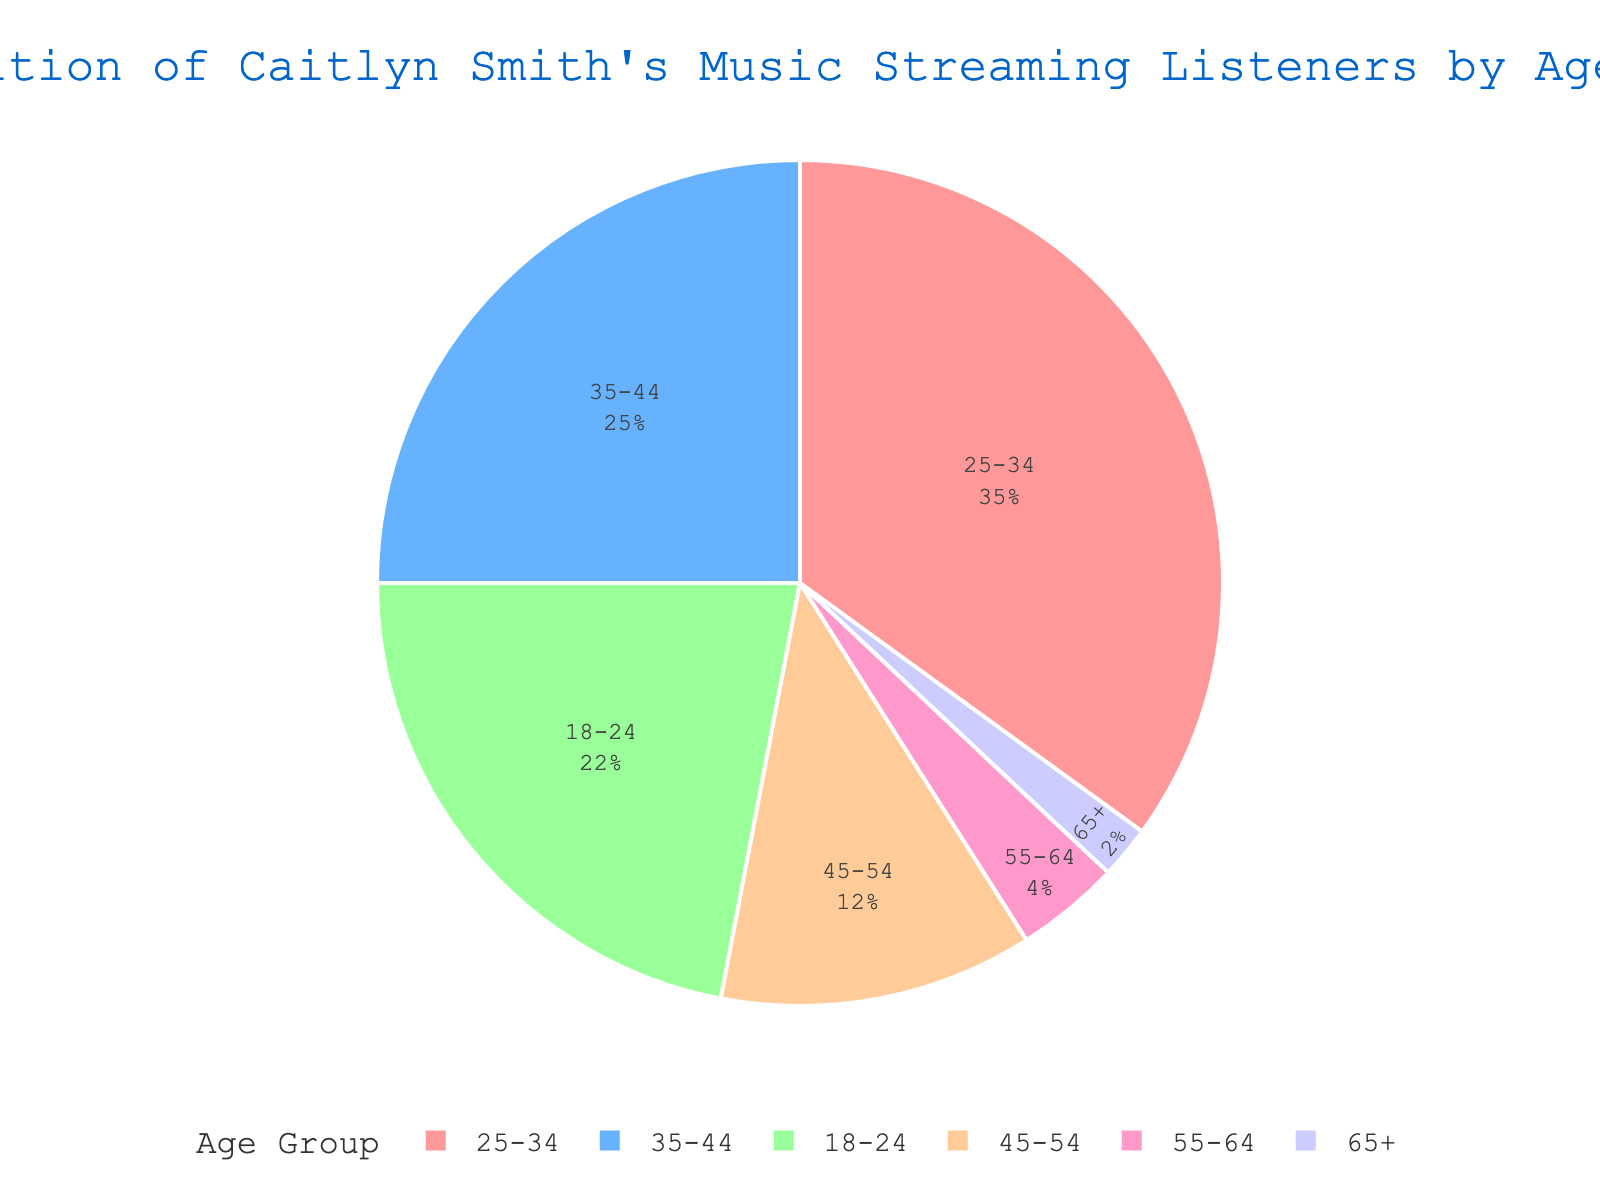What age group has the highest percentage of Caitlyn Smith's music streaming listeners? By examining the pie chart, it is clear that the 25-34 age group has the largest section. This is visually the largest slice in the pie chart.
Answer: 25-34 Which two age groups combined form more than 50% of the listeners? By adding the percentages for 25-34 (35%) and 35-44 (25%), we get 35 + 25 = 60, which is more than 50%.
Answer: 25-34 and 35-44 What is the percentage difference between the 18-24 and 65+ age groups? The chart shows 22% for 18-24 and 2% for 65+. Subtracting these gives 22 - 2 = 20.
Answer: 20% Which age group has just under double the percentage of the 45-54 age group? The 45-54 age group has 12%. The 35-44 age group has 25%, which is just over double 12%.
Answer: 35-44 If you combine the percentages of the 55-64 and 65+ age groups, would it exceed 10%? The 55-64 age group has 4% and the 65+ age group has 2%. Adding these gives 4 + 2 = 6%, which is less than 10%.
Answer: No What proportion of the listeners are aged 24 or younger? The 18-24 age group accounts for 22% of the listeners.
Answer: 22% Is there a considerable difference between the youngest and the oldest age groups in terms of percentage? The 18-24 group is 22% while the 65+ group is just 2%. The difference between these is 22 - 2 = 20%, which is considerable.
Answer: Yes Which age group would be represented by the color red in the chart? From the custom color palette provided, red is likely the first color, which corresponds to the first age group listed (18-24).
Answer: 18-24 